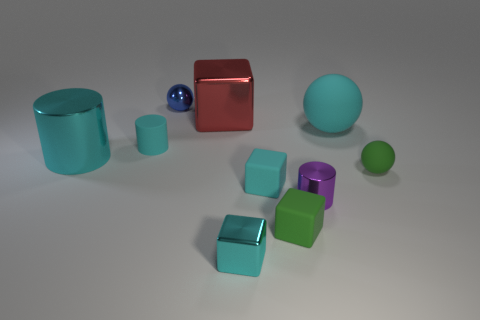Subtract all red cubes. How many cyan cylinders are left? 2 Subtract all tiny spheres. How many spheres are left? 1 Subtract 1 spheres. How many spheres are left? 2 Subtract all green cubes. How many cubes are left? 3 Subtract all brown blocks. Subtract all yellow cylinders. How many blocks are left? 4 Subtract all cylinders. How many objects are left? 7 Subtract 0 yellow cylinders. How many objects are left? 10 Subtract all tiny blue cylinders. Subtract all red metal objects. How many objects are left? 9 Add 6 cyan shiny cubes. How many cyan shiny cubes are left? 7 Add 3 tiny brown cubes. How many tiny brown cubes exist? 3 